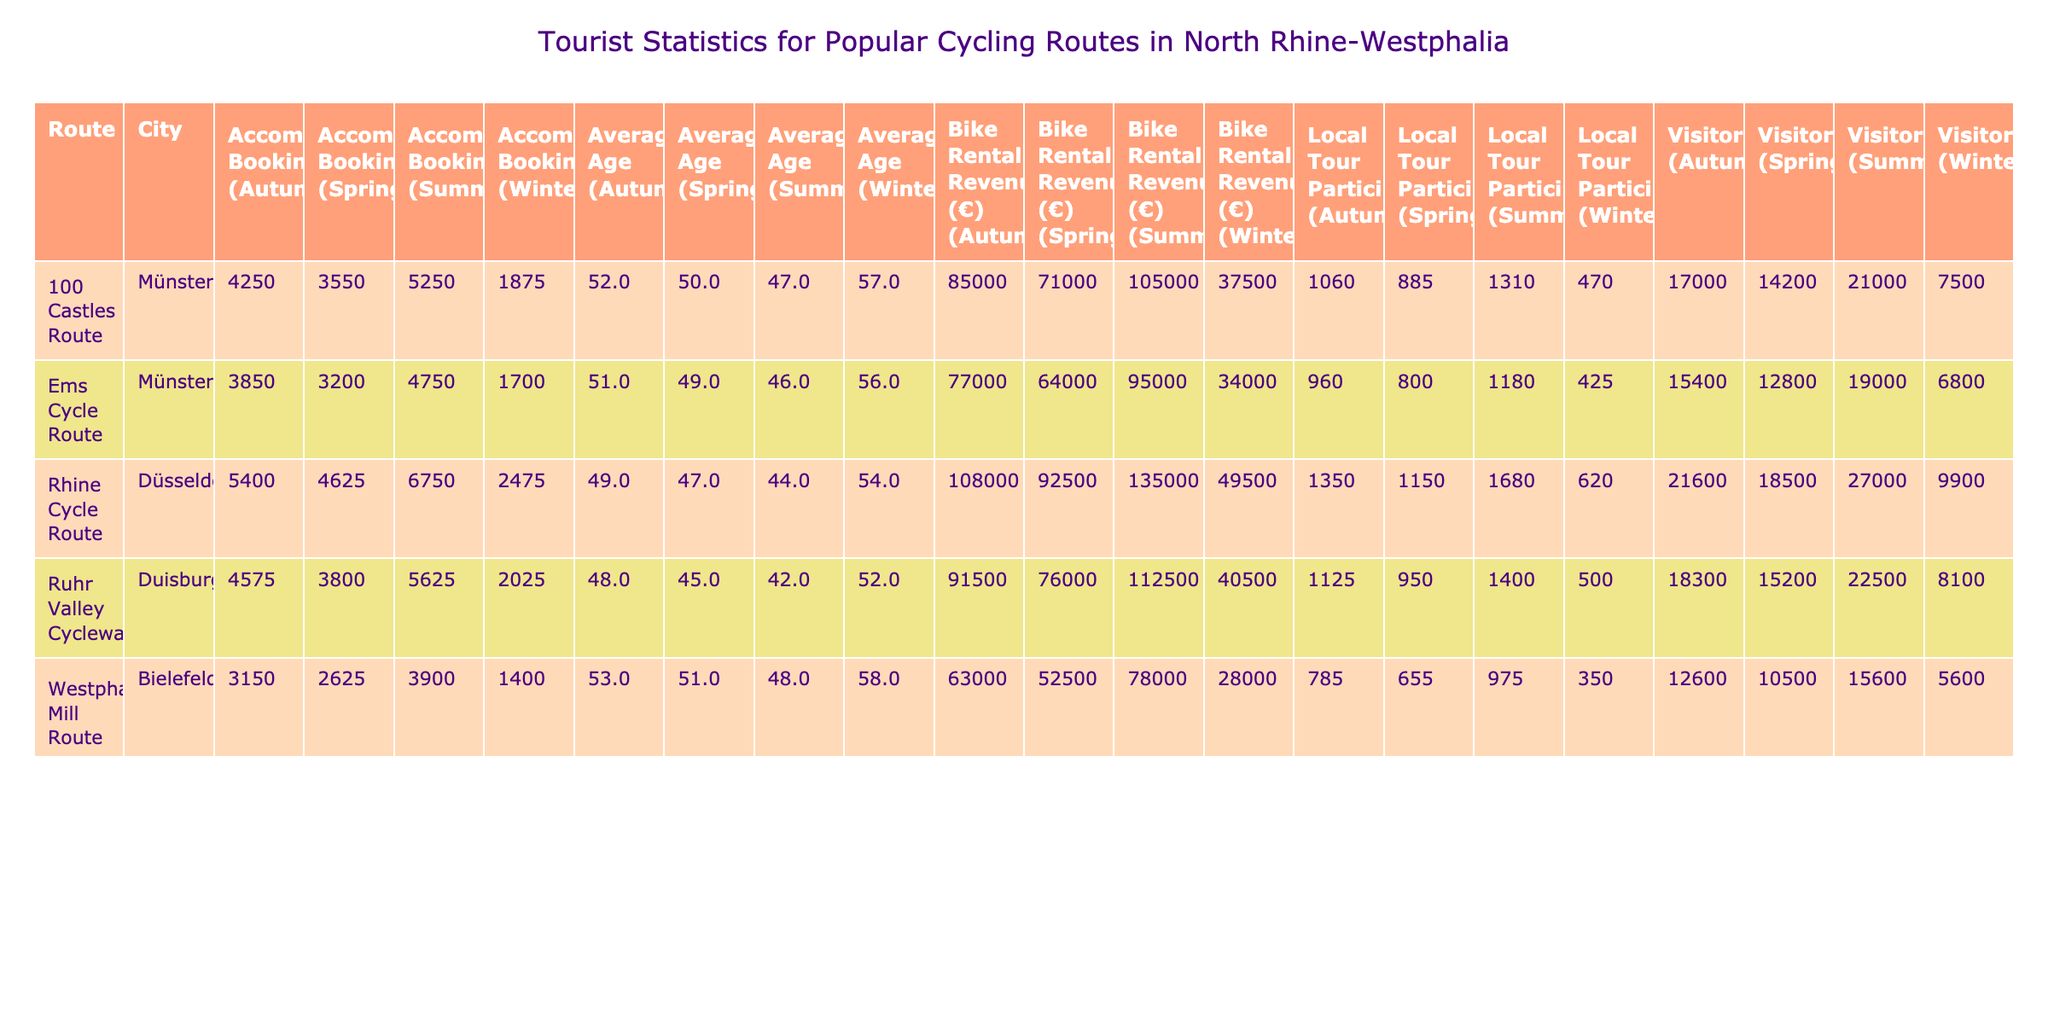what is the total number of visitors for the Ruhr Valley Cycleway in the summer season? From the table, we locate the Ruhr Valley Cycleway row under the Summer season, where the Visitors column shows 22500. Therefore, there's no need for calculation.
Answer: 22500 which cycling route had the highest average age of visitors in the Autumn season? Looking at the Autumn season column, we observe the average ages: Ruhr Valley Cycleway (48), Rhine Cycle Route (49), Ems Cycle Route (51), and Westphalian Mill Route (53). The Westphalian Mill Route has the highest average age of 53.
Answer: Westphalian Mill Route how many more local tour participants did the Rhine Cycle Route have in summer than in winter? For the Rhine Cycle Route, the Summer season has 1680 local tour participants, whereas the Winter season has 620. The difference is calculated as 1680 - 620 = 1060.
Answer: 1060 is the Bike Rental Revenue for the 100 Castles Route in Winter greater than the average for all routes in Winter? The Bike Rental Revenue for the 100 Castles Route in Winter is 37500. We need to compare it with the average revenue in Winter. The Winter revenue for each route is 40500, 49500, 34000, 28000, and 37500. The average is calculated as (40500 + 49500 + 34000 + 28000 + 37500) / 5 = 37300. Since 37500 > 37300, the statement is true.
Answer: Yes which city has the highest total number of visitors across all seasons? To find this, we sum the visitors for each city: Duisburg totals 59800 (15200 + 22500 + 18300 + 8100), Düsseldorf totals 62400 (18500 + 27000 + 21600 + 9900), Münster totals 58800 (12800 + 19000 + 15400 + 6800), and Bielefeld totals 37800 (10500 + 15600 + 12600 + 5600). The highest is Düsseldorf with 62400.
Answer: Düsseldorf how does the average number of visitors in Spring compare to Winter across all routes? The total number of visitors in Spring is 15200 + 18500 + 12800 + 10500 + 14200 = 71200; in Winter, it is 8100 + 9900 + 6800 + 5600 + 7500 = 37900. The average difference is calculated as 71200 - 37900 = 33300, indicating significantly more visitors in Spring.
Answer: Spring has 33300 more visitors than Winter 